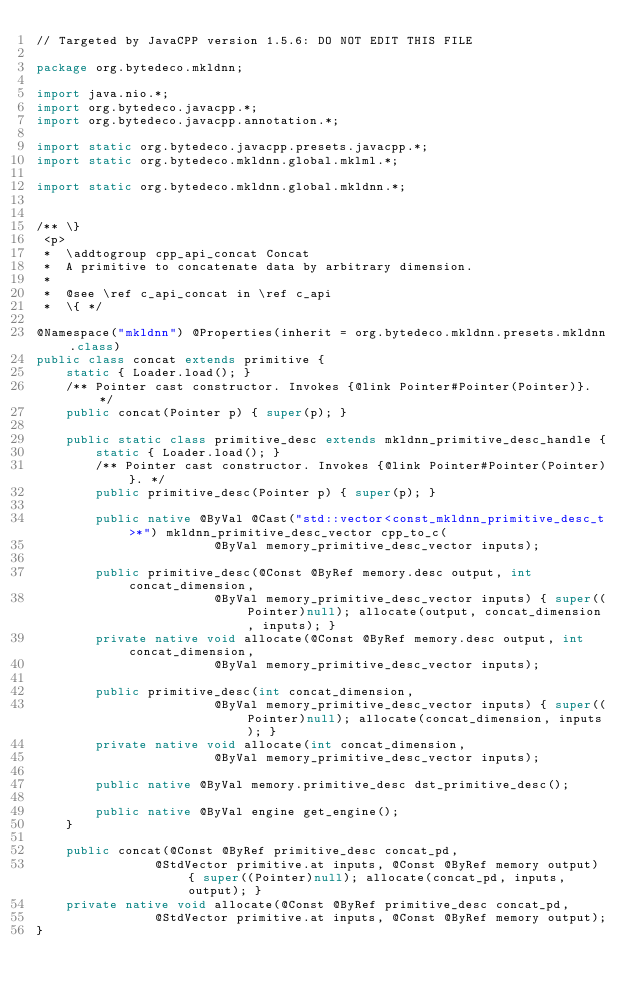Convert code to text. <code><loc_0><loc_0><loc_500><loc_500><_Java_>// Targeted by JavaCPP version 1.5.6: DO NOT EDIT THIS FILE

package org.bytedeco.mkldnn;

import java.nio.*;
import org.bytedeco.javacpp.*;
import org.bytedeco.javacpp.annotation.*;

import static org.bytedeco.javacpp.presets.javacpp.*;
import static org.bytedeco.mkldnn.global.mklml.*;

import static org.bytedeco.mkldnn.global.mkldnn.*;


/** \}
 <p>
 *  \addtogroup cpp_api_concat Concat
 *  A primitive to concatenate data by arbitrary dimension.
 * 
 *  @see \ref c_api_concat in \ref c_api
 *  \{ */

@Namespace("mkldnn") @Properties(inherit = org.bytedeco.mkldnn.presets.mkldnn.class)
public class concat extends primitive {
    static { Loader.load(); }
    /** Pointer cast constructor. Invokes {@link Pointer#Pointer(Pointer)}. */
    public concat(Pointer p) { super(p); }

    public static class primitive_desc extends mkldnn_primitive_desc_handle {
        static { Loader.load(); }
        /** Pointer cast constructor. Invokes {@link Pointer#Pointer(Pointer)}. */
        public primitive_desc(Pointer p) { super(p); }
    
        public native @ByVal @Cast("std::vector<const_mkldnn_primitive_desc_t>*") mkldnn_primitive_desc_vector cpp_to_c(
                        @ByVal memory_primitive_desc_vector inputs);

        public primitive_desc(@Const @ByRef memory.desc output, int concat_dimension,
                        @ByVal memory_primitive_desc_vector inputs) { super((Pointer)null); allocate(output, concat_dimension, inputs); }
        private native void allocate(@Const @ByRef memory.desc output, int concat_dimension,
                        @ByVal memory_primitive_desc_vector inputs);

        public primitive_desc(int concat_dimension,
                        @ByVal memory_primitive_desc_vector inputs) { super((Pointer)null); allocate(concat_dimension, inputs); }
        private native void allocate(int concat_dimension,
                        @ByVal memory_primitive_desc_vector inputs);

        public native @ByVal memory.primitive_desc dst_primitive_desc();

        public native @ByVal engine get_engine();
    }

    public concat(@Const @ByRef primitive_desc concat_pd,
                @StdVector primitive.at inputs, @Const @ByRef memory output) { super((Pointer)null); allocate(concat_pd, inputs, output); }
    private native void allocate(@Const @ByRef primitive_desc concat_pd,
                @StdVector primitive.at inputs, @Const @ByRef memory output);
}
</code> 